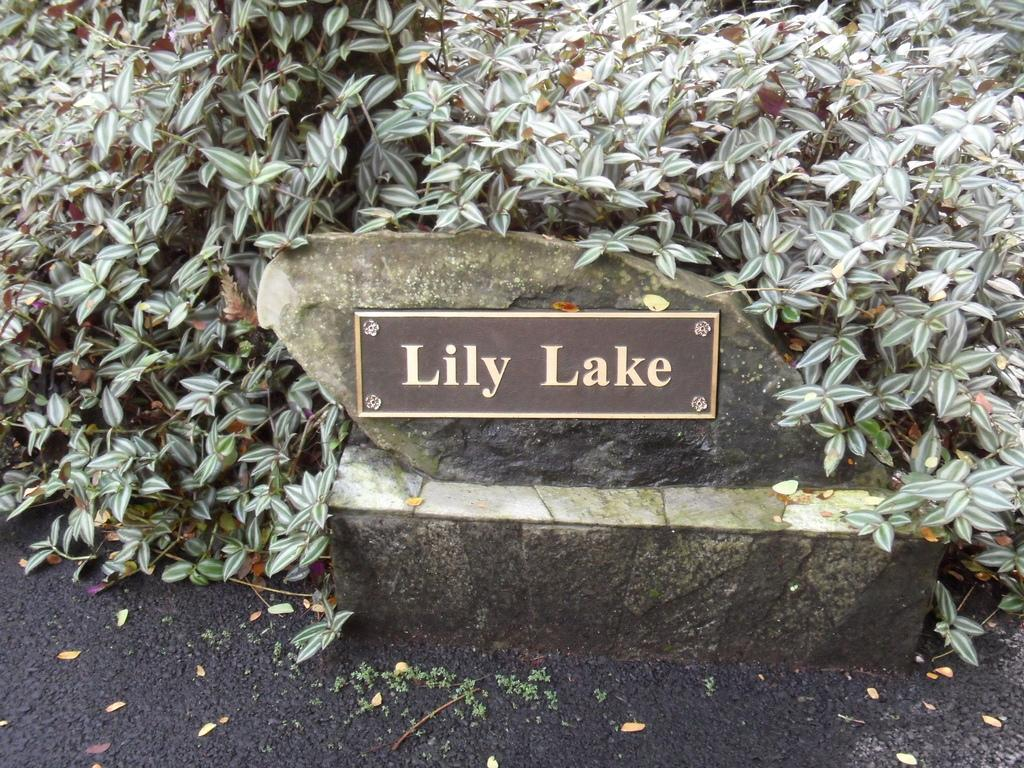What is the main object in the image? There is a board in the image. What is the board placed on? The board is placed on a stone. What type of vegetation is present in the image? There are plants in the image, and many leaves are visible. Can you describe the possible location of the image? There might be a road at the bottom of the image, which could suggest an outdoor setting. How does the board affect the throat in the image? The board does not affect the throat in the image, as it is an inanimate object and not related to any living being or their throat. 